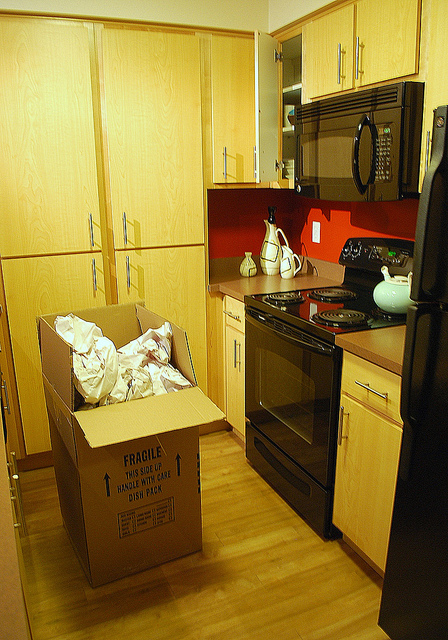Extract all visible text content from this image. FRAGILE 